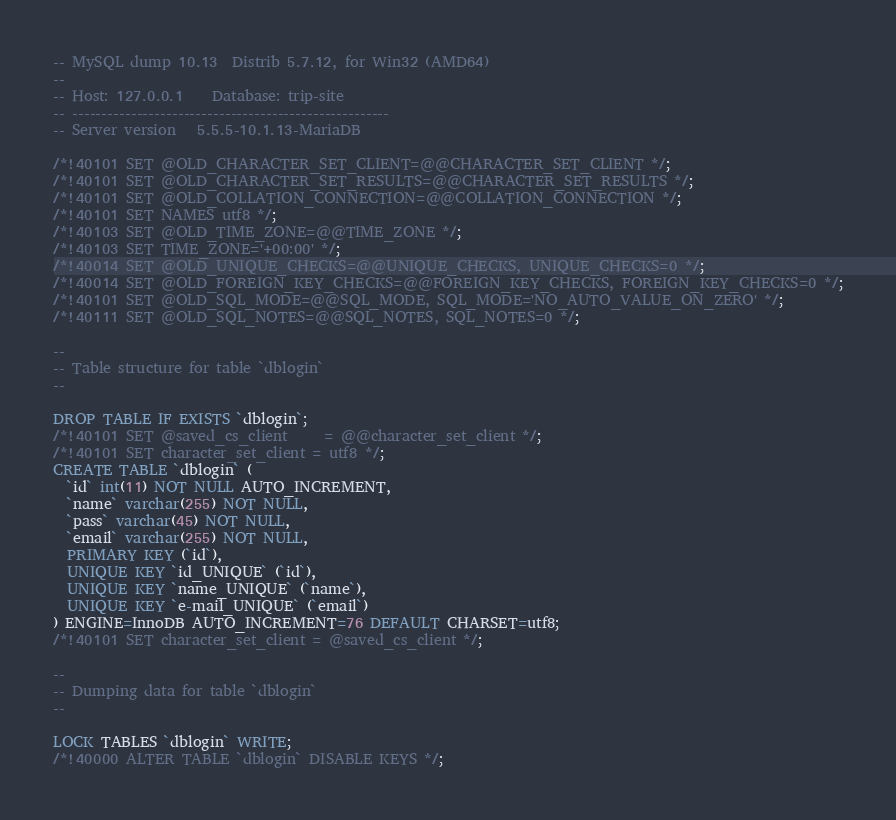<code> <loc_0><loc_0><loc_500><loc_500><_SQL_>-- MySQL dump 10.13  Distrib 5.7.12, for Win32 (AMD64)
--
-- Host: 127.0.0.1    Database: trip-site
-- ------------------------------------------------------
-- Server version	5.5.5-10.1.13-MariaDB

/*!40101 SET @OLD_CHARACTER_SET_CLIENT=@@CHARACTER_SET_CLIENT */;
/*!40101 SET @OLD_CHARACTER_SET_RESULTS=@@CHARACTER_SET_RESULTS */;
/*!40101 SET @OLD_COLLATION_CONNECTION=@@COLLATION_CONNECTION */;
/*!40101 SET NAMES utf8 */;
/*!40103 SET @OLD_TIME_ZONE=@@TIME_ZONE */;
/*!40103 SET TIME_ZONE='+00:00' */;
/*!40014 SET @OLD_UNIQUE_CHECKS=@@UNIQUE_CHECKS, UNIQUE_CHECKS=0 */;
/*!40014 SET @OLD_FOREIGN_KEY_CHECKS=@@FOREIGN_KEY_CHECKS, FOREIGN_KEY_CHECKS=0 */;
/*!40101 SET @OLD_SQL_MODE=@@SQL_MODE, SQL_MODE='NO_AUTO_VALUE_ON_ZERO' */;
/*!40111 SET @OLD_SQL_NOTES=@@SQL_NOTES, SQL_NOTES=0 */;

--
-- Table structure for table `dblogin`
--

DROP TABLE IF EXISTS `dblogin`;
/*!40101 SET @saved_cs_client     = @@character_set_client */;
/*!40101 SET character_set_client = utf8 */;
CREATE TABLE `dblogin` (
  `id` int(11) NOT NULL AUTO_INCREMENT,
  `name` varchar(255) NOT NULL,
  `pass` varchar(45) NOT NULL,
  `email` varchar(255) NOT NULL,
  PRIMARY KEY (`id`),
  UNIQUE KEY `id_UNIQUE` (`id`),
  UNIQUE KEY `name_UNIQUE` (`name`),
  UNIQUE KEY `e-mail_UNIQUE` (`email`)
) ENGINE=InnoDB AUTO_INCREMENT=76 DEFAULT CHARSET=utf8;
/*!40101 SET character_set_client = @saved_cs_client */;

--
-- Dumping data for table `dblogin`
--

LOCK TABLES `dblogin` WRITE;
/*!40000 ALTER TABLE `dblogin` DISABLE KEYS */;</code> 